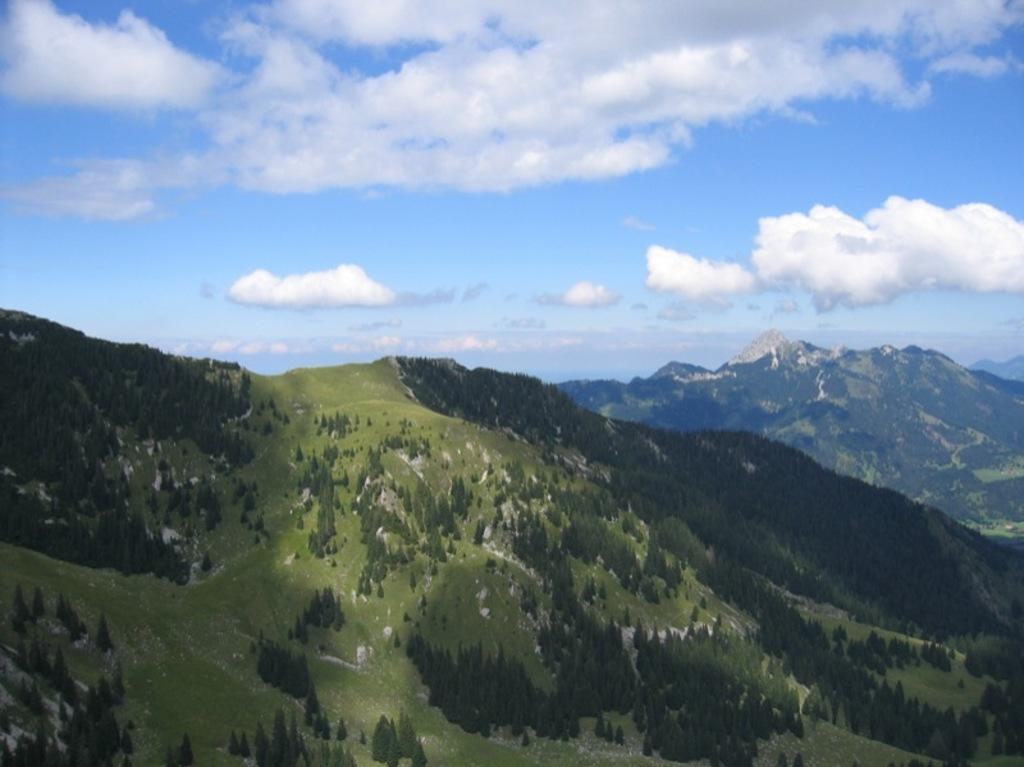What type of natural formation can be seen in the image? There are mountains in the image. What covers the mountains in the image? The mountains are covered with trees and plants. What is visible in the sky in the image? There are clouds in the sky. How many jellyfish can be seen swimming in the image? There are no jellyfish present in the image; it features mountains covered with trees and plants. What type of creature is sleeping in the crib in the image? There is no crib or creature present in the image. 